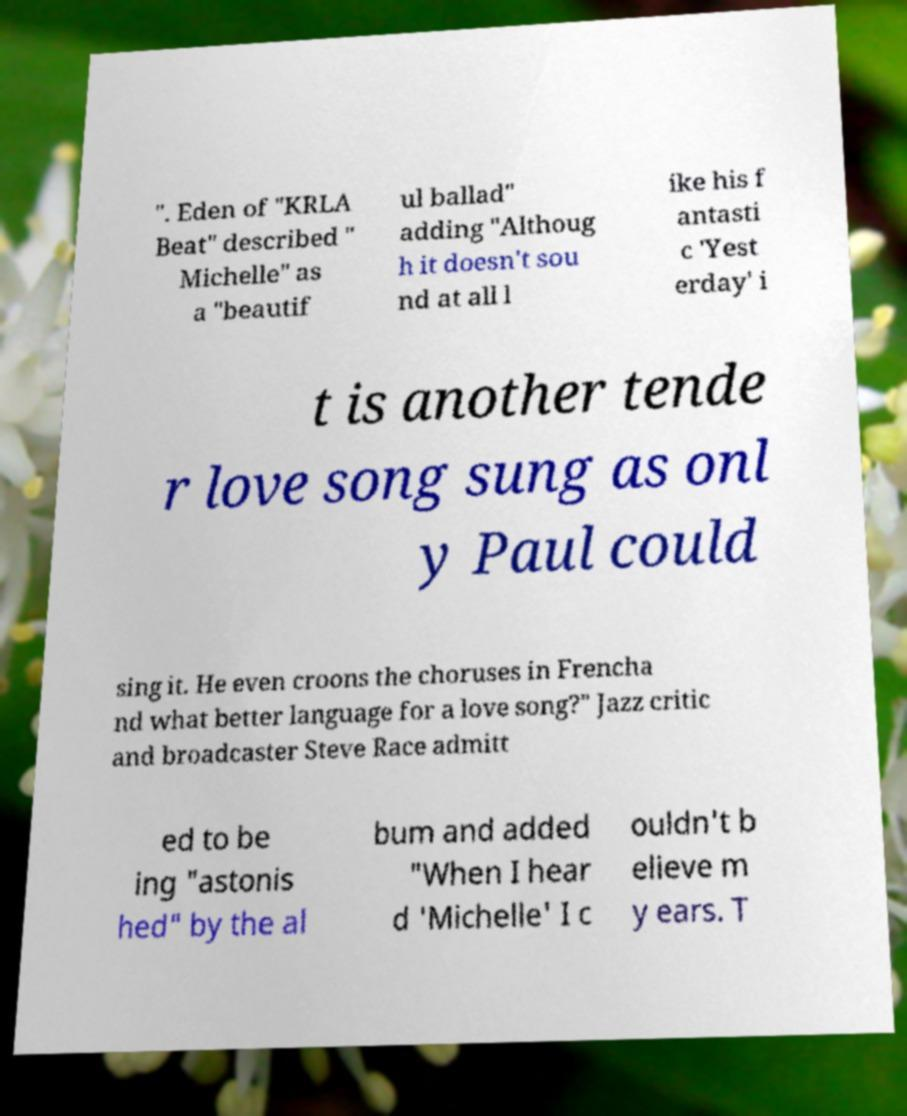Please read and relay the text visible in this image. What does it say? ". Eden of "KRLA Beat" described " Michelle" as a "beautif ul ballad" adding "Althoug h it doesn't sou nd at all l ike his f antasti c 'Yest erday' i t is another tende r love song sung as onl y Paul could sing it. He even croons the choruses in Frencha nd what better language for a love song?" Jazz critic and broadcaster Steve Race admitt ed to be ing "astonis hed" by the al bum and added "When I hear d 'Michelle' I c ouldn't b elieve m y ears. T 